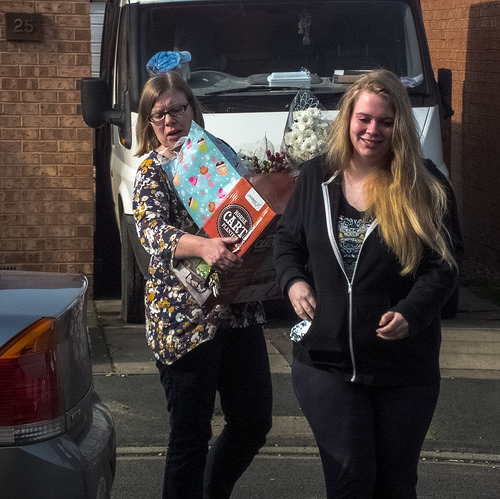<image>
Is the women in front of the car? Yes. The women is positioned in front of the car, appearing closer to the camera viewpoint. 